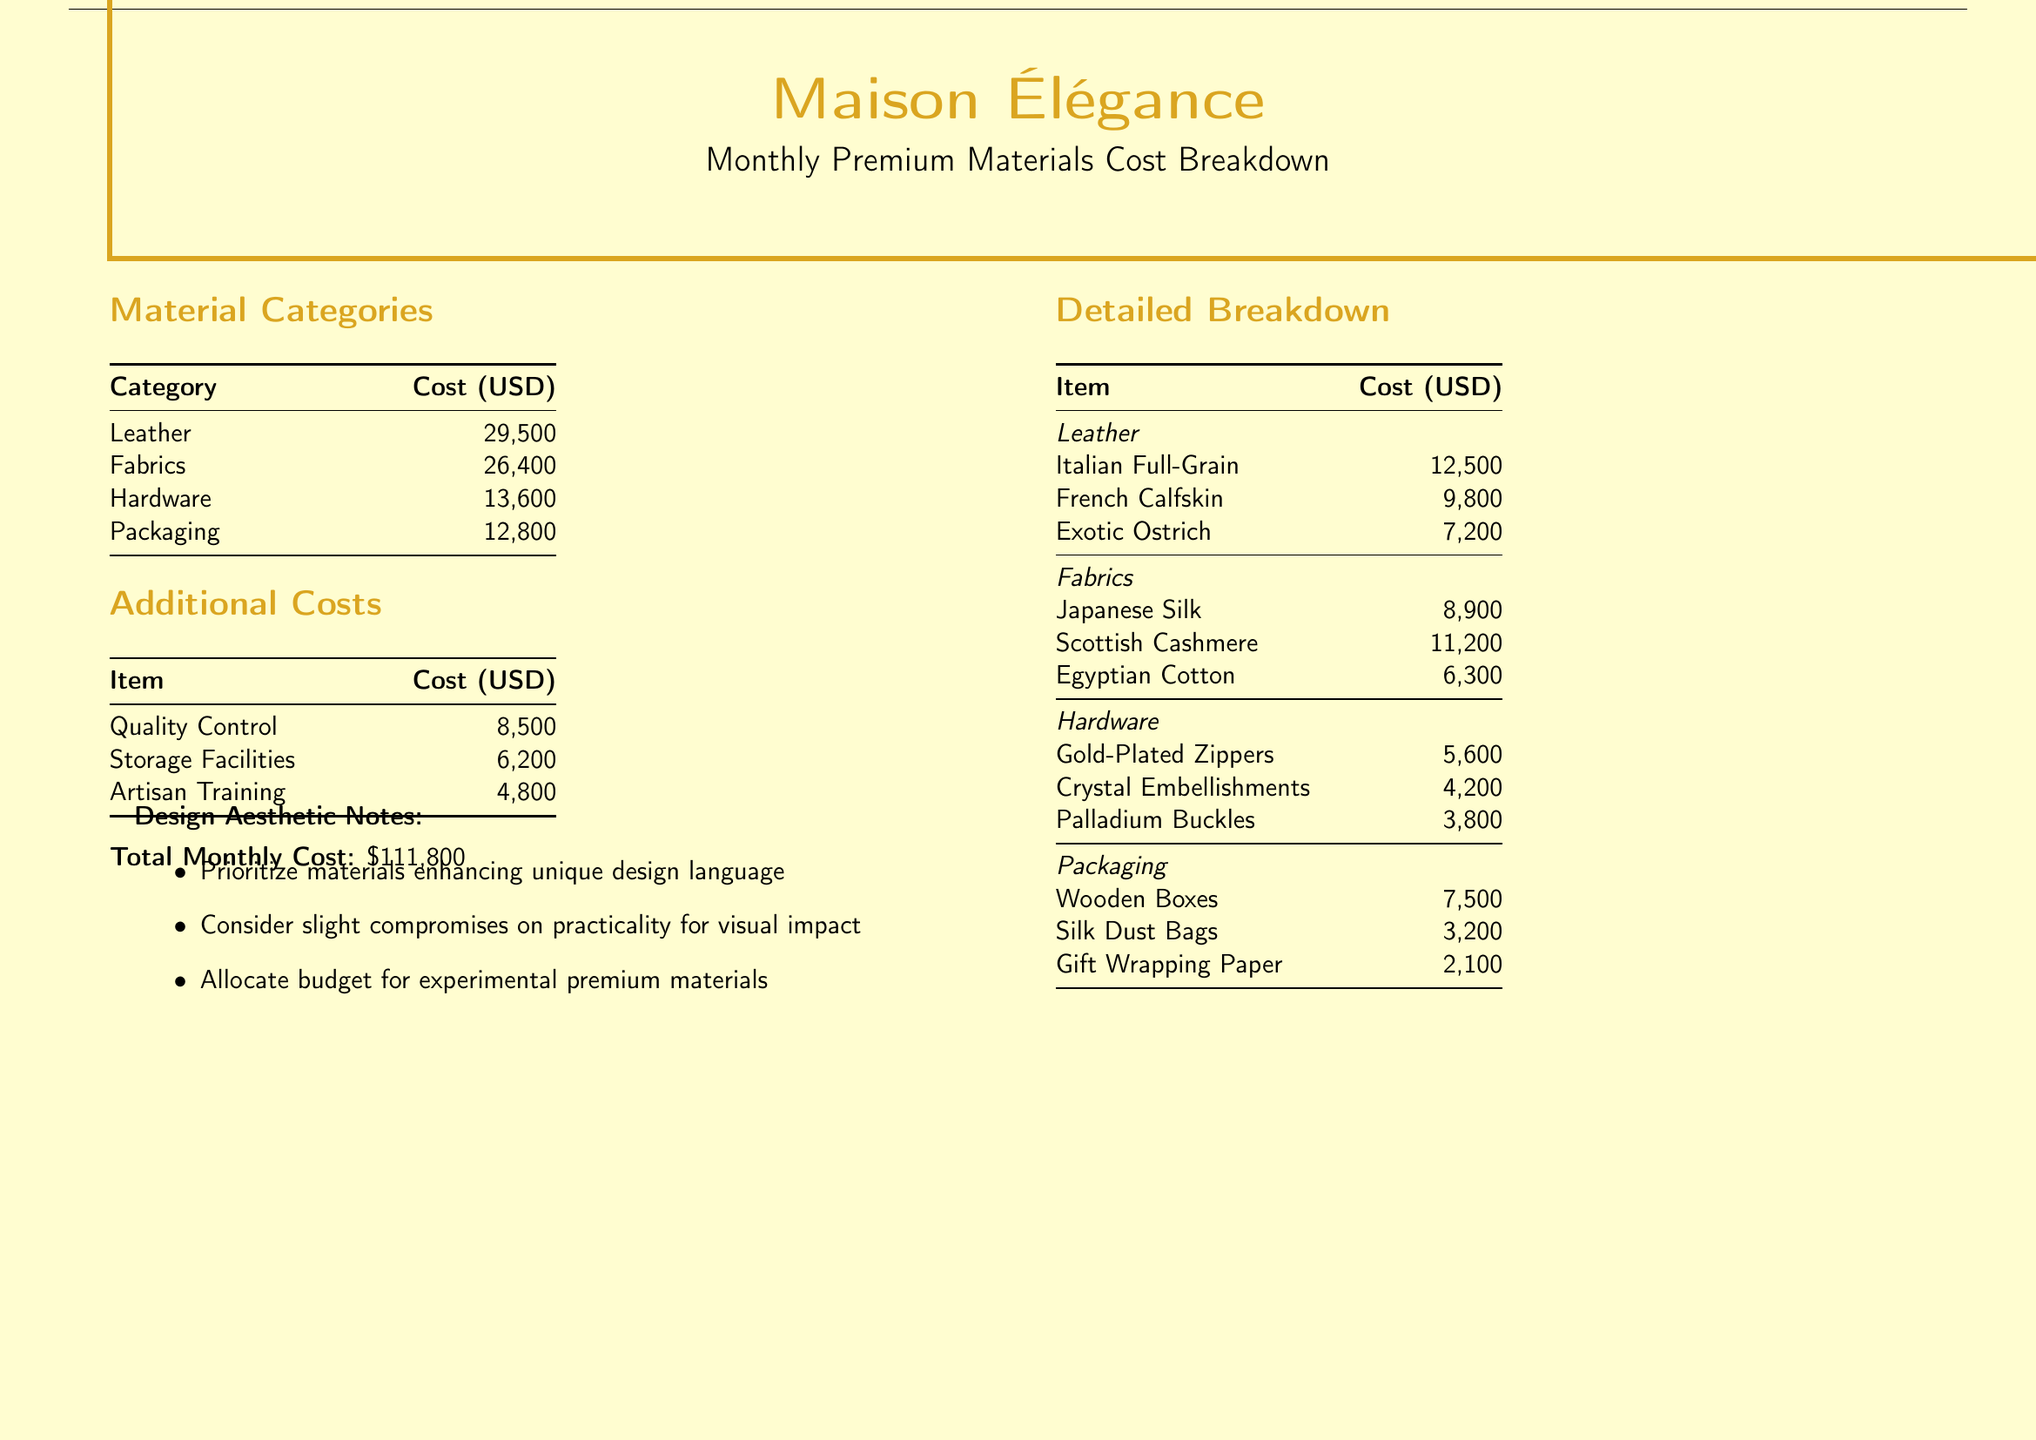what is the total monthly cost? The total monthly cost is stated at the bottom of the document, which adds all individual costs together.
Answer: $111,800 how much is spent on leather? The document specifies the cost for leather as a category in the material breakdown section, which lists its total cost.
Answer: $29,500 which fabric is the most expensive? The detailed breakdown section lists all fabrics and their costs, and we can identify the most expensive one by comparing the costs.
Answer: Scottish Cashmere what is the cost of quality control? The document shows a separate table for additional costs, in which quality control costs are mentioned.
Answer: $8,500 how much is allocated for artisan training? The text mentions artisan training as one of the additional costs, providing its specific cost.
Answer: $4,800 what material has the highest cost within hardware? By reviewing the detailed breakdown of hardware, we can identify the highest cost item in that category.
Answer: Gold-Plated Zippers what percentage of the total cost is spent on fabrics? By calculating the cost of fabrics and comparing it to the total monthly cost, we can determine its percentage of the whole.
Answer: 23.6% what is a key note regarding design aesthetics? The last section of the document includes several design aesthetic notes, requiring synthesis of the information to find a key takeaway.
Answer: Prioritize materials enhancing unique design language how much is spent on silk dust bags? This cost is detailed under the packaging section of the document's detailed breakdown, which enumerates specific costs.
Answer: $3,200 